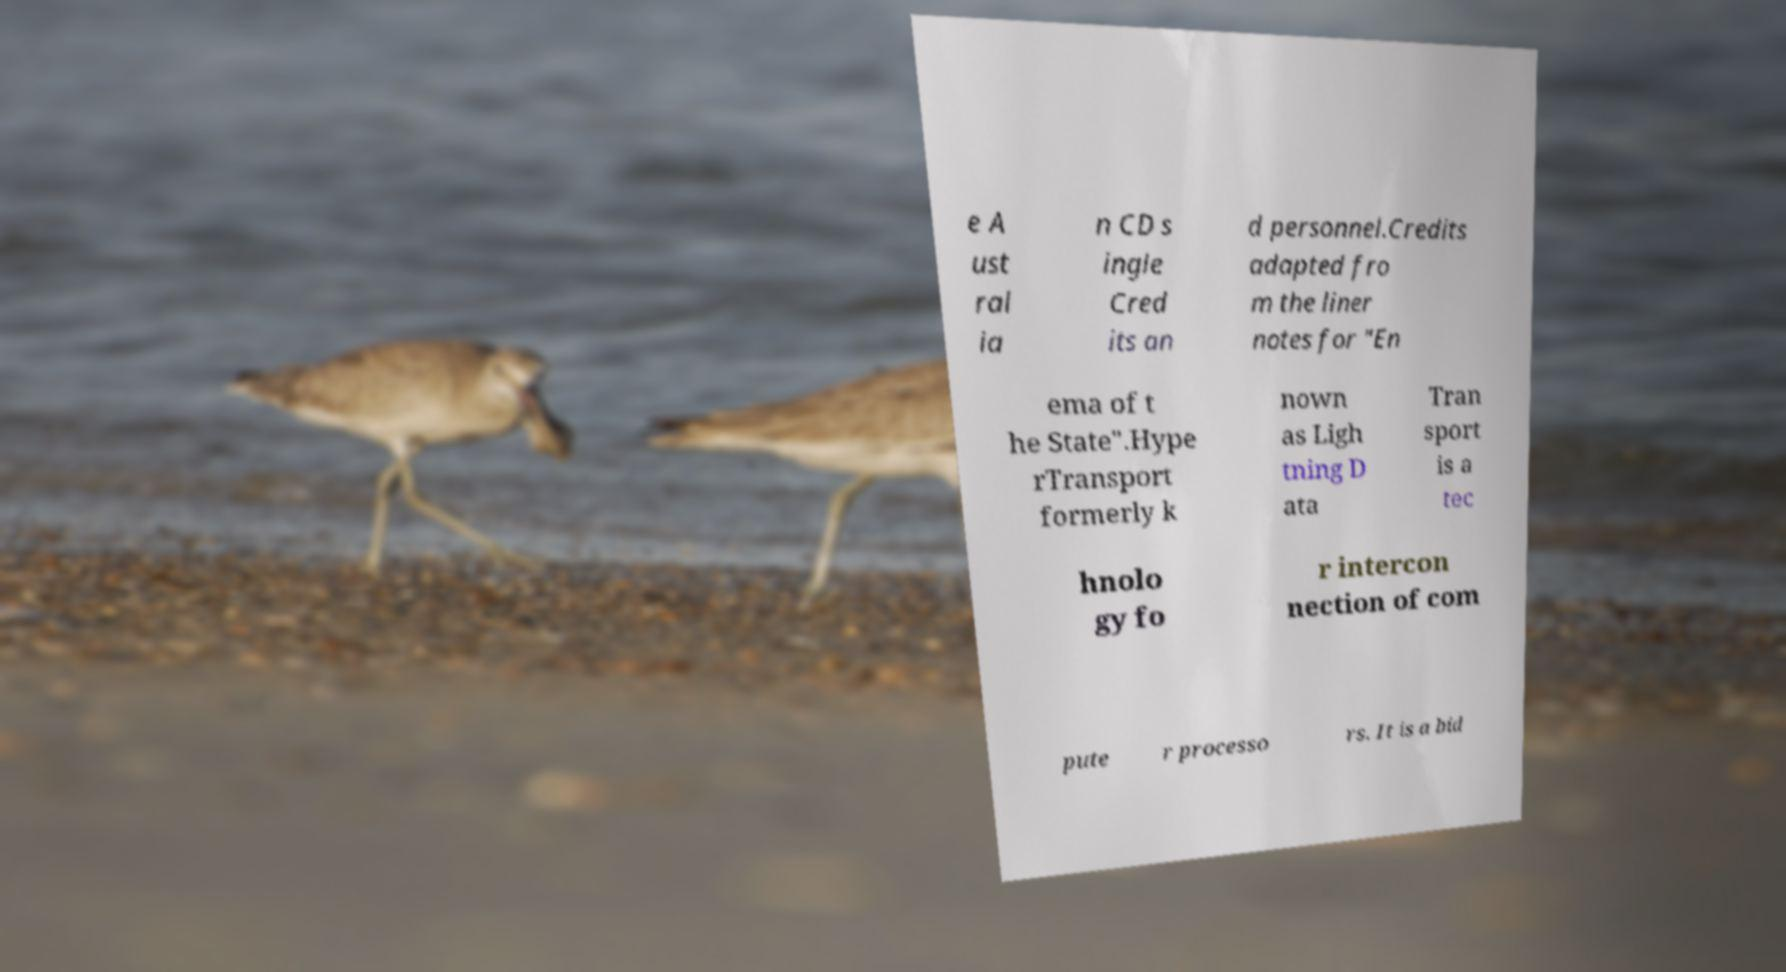What messages or text are displayed in this image? I need them in a readable, typed format. e A ust ral ia n CD s ingle Cred its an d personnel.Credits adapted fro m the liner notes for "En ema of t he State".Hype rTransport formerly k nown as Ligh tning D ata Tran sport is a tec hnolo gy fo r intercon nection of com pute r processo rs. It is a bid 